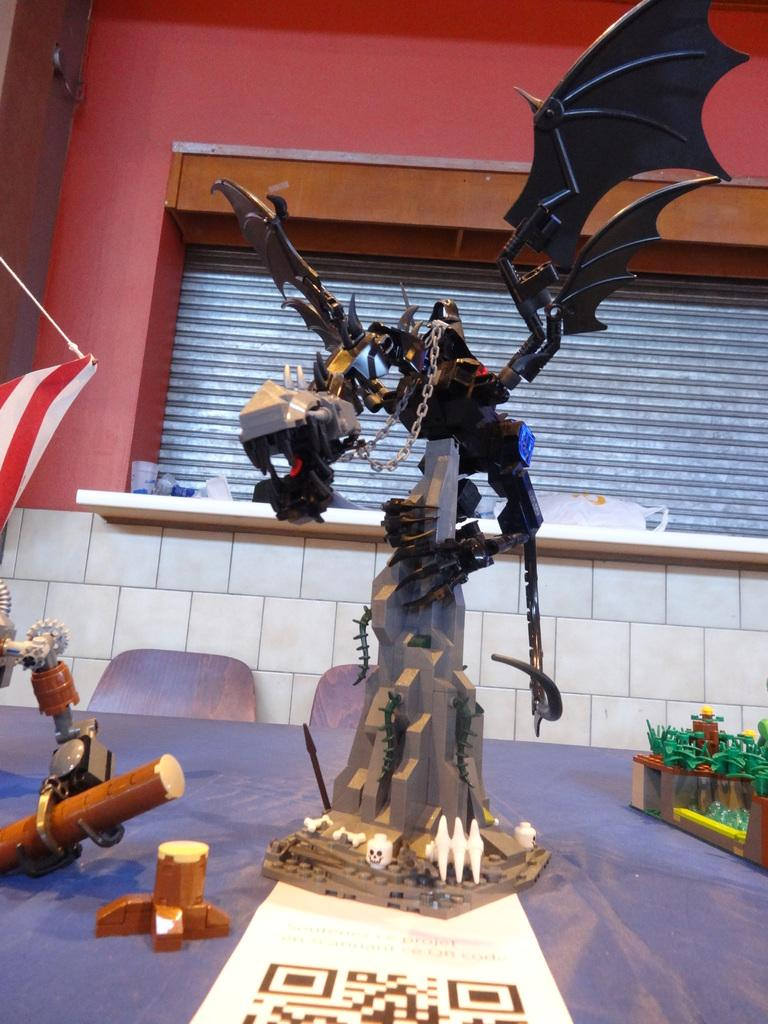What type of toy is featured on the mountain in the image? There is a toy of a dragon on a mountain in the image. What other toys can be seen in the image? There are additional toys on a table in the image. What can be seen in the background of the image? There is a wall and a shutter in the background of the image. What type of substance is being used to clean the shoes in the image? There is no mention of shoes or cleaning substances in the image; it features a dragon toy on a mountain and additional toys on a table. 